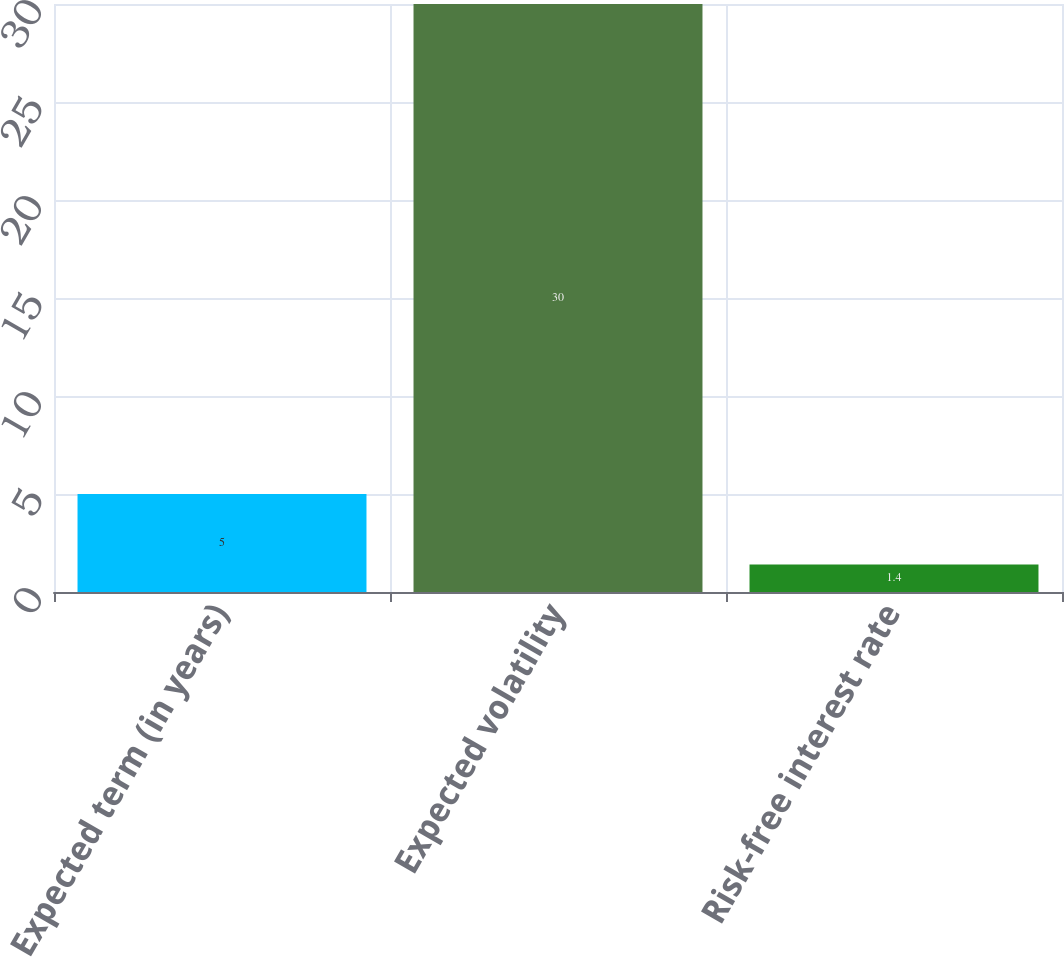<chart> <loc_0><loc_0><loc_500><loc_500><bar_chart><fcel>Expected term (in years)<fcel>Expected volatility<fcel>Risk-free interest rate<nl><fcel>5<fcel>30<fcel>1.4<nl></chart> 